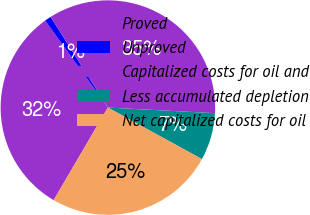Convert chart to OTSL. <chart><loc_0><loc_0><loc_500><loc_500><pie_chart><fcel>Proved<fcel>Unproved<fcel>Capitalized costs for oil and<fcel>Less accumulated depletion<fcel>Net capitalized costs for oil<nl><fcel>31.63%<fcel>0.98%<fcel>34.79%<fcel>7.15%<fcel>25.46%<nl></chart> 